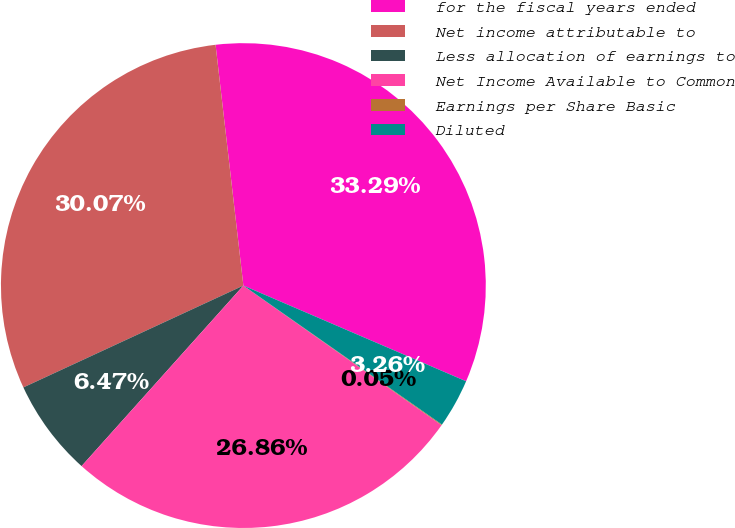Convert chart. <chart><loc_0><loc_0><loc_500><loc_500><pie_chart><fcel>for the fiscal years ended<fcel>Net income attributable to<fcel>Less allocation of earnings to<fcel>Net Income Available to Common<fcel>Earnings per Share Basic<fcel>Diluted<nl><fcel>33.29%<fcel>30.07%<fcel>6.47%<fcel>26.86%<fcel>0.05%<fcel>3.26%<nl></chart> 